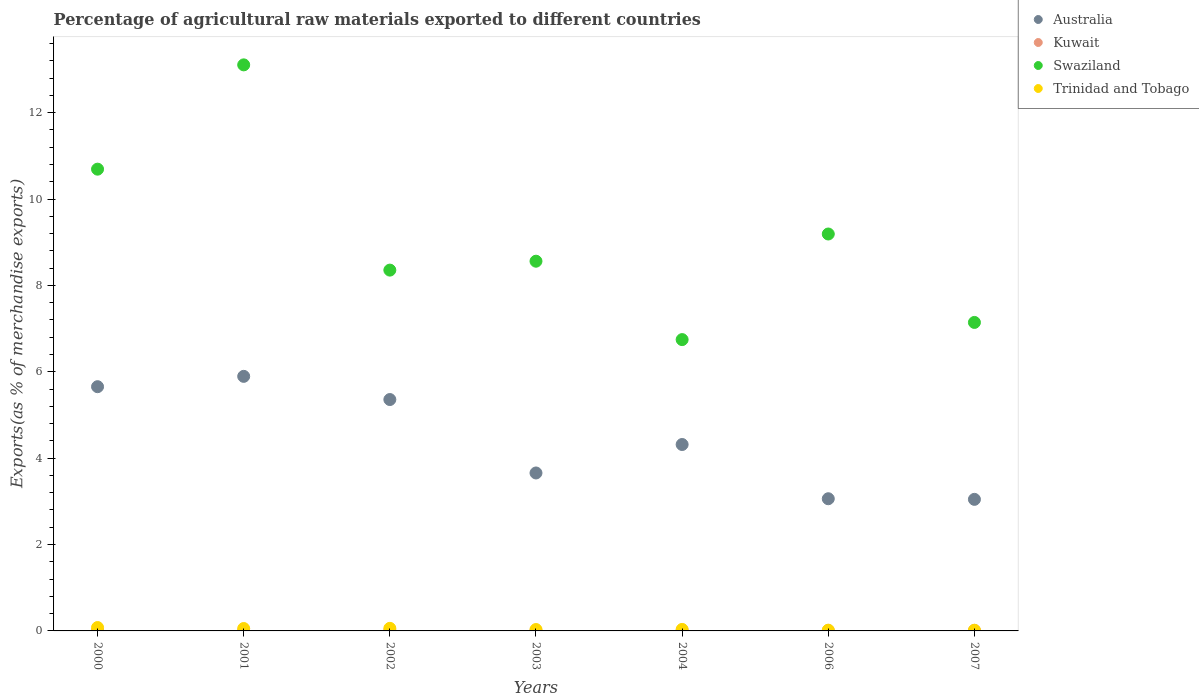Is the number of dotlines equal to the number of legend labels?
Offer a terse response. Yes. What is the percentage of exports to different countries in Trinidad and Tobago in 2002?
Your answer should be compact. 0.06. Across all years, what is the maximum percentage of exports to different countries in Trinidad and Tobago?
Your response must be concise. 0.08. Across all years, what is the minimum percentage of exports to different countries in Trinidad and Tobago?
Your answer should be compact. 0.02. In which year was the percentage of exports to different countries in Swaziland maximum?
Offer a terse response. 2001. What is the total percentage of exports to different countries in Swaziland in the graph?
Offer a very short reply. 63.79. What is the difference between the percentage of exports to different countries in Swaziland in 2001 and that in 2004?
Keep it short and to the point. 6.36. What is the difference between the percentage of exports to different countries in Swaziland in 2003 and the percentage of exports to different countries in Kuwait in 2001?
Ensure brevity in your answer.  8.55. What is the average percentage of exports to different countries in Swaziland per year?
Provide a succinct answer. 9.11. In the year 2007, what is the difference between the percentage of exports to different countries in Swaziland and percentage of exports to different countries in Australia?
Your response must be concise. 4.1. In how many years, is the percentage of exports to different countries in Australia greater than 6.4 %?
Make the answer very short. 0. What is the ratio of the percentage of exports to different countries in Trinidad and Tobago in 2004 to that in 2006?
Offer a terse response. 1.97. Is the percentage of exports to different countries in Swaziland in 2000 less than that in 2002?
Your answer should be very brief. No. Is the difference between the percentage of exports to different countries in Swaziland in 2004 and 2007 greater than the difference between the percentage of exports to different countries in Australia in 2004 and 2007?
Give a very brief answer. No. What is the difference between the highest and the second highest percentage of exports to different countries in Swaziland?
Your answer should be very brief. 2.41. What is the difference between the highest and the lowest percentage of exports to different countries in Australia?
Your response must be concise. 2.85. In how many years, is the percentage of exports to different countries in Kuwait greater than the average percentage of exports to different countries in Kuwait taken over all years?
Offer a very short reply. 3. Is the sum of the percentage of exports to different countries in Swaziland in 2002 and 2007 greater than the maximum percentage of exports to different countries in Trinidad and Tobago across all years?
Your answer should be very brief. Yes. Is it the case that in every year, the sum of the percentage of exports to different countries in Kuwait and percentage of exports to different countries in Australia  is greater than the percentage of exports to different countries in Swaziland?
Your response must be concise. No. How many dotlines are there?
Offer a very short reply. 4. How many years are there in the graph?
Make the answer very short. 7. Are the values on the major ticks of Y-axis written in scientific E-notation?
Your answer should be compact. No. Does the graph contain grids?
Provide a succinct answer. No. How many legend labels are there?
Offer a terse response. 4. How are the legend labels stacked?
Your response must be concise. Vertical. What is the title of the graph?
Keep it short and to the point. Percentage of agricultural raw materials exported to different countries. What is the label or title of the X-axis?
Your answer should be compact. Years. What is the label or title of the Y-axis?
Offer a very short reply. Exports(as % of merchandise exports). What is the Exports(as % of merchandise exports) of Australia in 2000?
Give a very brief answer. 5.65. What is the Exports(as % of merchandise exports) of Kuwait in 2000?
Give a very brief answer. 0.01. What is the Exports(as % of merchandise exports) in Swaziland in 2000?
Your answer should be compact. 10.69. What is the Exports(as % of merchandise exports) in Trinidad and Tobago in 2000?
Your answer should be very brief. 0.08. What is the Exports(as % of merchandise exports) of Australia in 2001?
Your response must be concise. 5.89. What is the Exports(as % of merchandise exports) of Kuwait in 2001?
Your answer should be compact. 0.01. What is the Exports(as % of merchandise exports) in Swaziland in 2001?
Provide a short and direct response. 13.11. What is the Exports(as % of merchandise exports) of Trinidad and Tobago in 2001?
Offer a terse response. 0.06. What is the Exports(as % of merchandise exports) in Australia in 2002?
Offer a very short reply. 5.36. What is the Exports(as % of merchandise exports) in Kuwait in 2002?
Provide a succinct answer. 0.01. What is the Exports(as % of merchandise exports) in Swaziland in 2002?
Your answer should be compact. 8.35. What is the Exports(as % of merchandise exports) in Trinidad and Tobago in 2002?
Give a very brief answer. 0.06. What is the Exports(as % of merchandise exports) of Australia in 2003?
Provide a short and direct response. 3.66. What is the Exports(as % of merchandise exports) in Kuwait in 2003?
Ensure brevity in your answer.  0.01. What is the Exports(as % of merchandise exports) of Swaziland in 2003?
Offer a very short reply. 8.56. What is the Exports(as % of merchandise exports) of Trinidad and Tobago in 2003?
Give a very brief answer. 0.03. What is the Exports(as % of merchandise exports) of Australia in 2004?
Make the answer very short. 4.32. What is the Exports(as % of merchandise exports) in Kuwait in 2004?
Your answer should be compact. 0.01. What is the Exports(as % of merchandise exports) of Swaziland in 2004?
Offer a terse response. 6.74. What is the Exports(as % of merchandise exports) in Trinidad and Tobago in 2004?
Provide a short and direct response. 0.03. What is the Exports(as % of merchandise exports) in Australia in 2006?
Provide a succinct answer. 3.06. What is the Exports(as % of merchandise exports) in Kuwait in 2006?
Make the answer very short. 0.01. What is the Exports(as % of merchandise exports) in Swaziland in 2006?
Provide a short and direct response. 9.19. What is the Exports(as % of merchandise exports) of Trinidad and Tobago in 2006?
Offer a terse response. 0.02. What is the Exports(as % of merchandise exports) in Australia in 2007?
Keep it short and to the point. 3.05. What is the Exports(as % of merchandise exports) of Kuwait in 2007?
Offer a very short reply. 0.01. What is the Exports(as % of merchandise exports) of Swaziland in 2007?
Give a very brief answer. 7.14. What is the Exports(as % of merchandise exports) in Trinidad and Tobago in 2007?
Your answer should be very brief. 0.02. Across all years, what is the maximum Exports(as % of merchandise exports) of Australia?
Your response must be concise. 5.89. Across all years, what is the maximum Exports(as % of merchandise exports) in Kuwait?
Provide a short and direct response. 0.01. Across all years, what is the maximum Exports(as % of merchandise exports) in Swaziland?
Offer a terse response. 13.11. Across all years, what is the maximum Exports(as % of merchandise exports) of Trinidad and Tobago?
Offer a terse response. 0.08. Across all years, what is the minimum Exports(as % of merchandise exports) in Australia?
Give a very brief answer. 3.05. Across all years, what is the minimum Exports(as % of merchandise exports) of Kuwait?
Provide a short and direct response. 0.01. Across all years, what is the minimum Exports(as % of merchandise exports) in Swaziland?
Offer a very short reply. 6.74. Across all years, what is the minimum Exports(as % of merchandise exports) of Trinidad and Tobago?
Make the answer very short. 0.02. What is the total Exports(as % of merchandise exports) of Australia in the graph?
Your answer should be compact. 30.99. What is the total Exports(as % of merchandise exports) of Kuwait in the graph?
Offer a terse response. 0.07. What is the total Exports(as % of merchandise exports) in Swaziland in the graph?
Give a very brief answer. 63.79. What is the total Exports(as % of merchandise exports) in Trinidad and Tobago in the graph?
Offer a very short reply. 0.29. What is the difference between the Exports(as % of merchandise exports) of Australia in 2000 and that in 2001?
Make the answer very short. -0.24. What is the difference between the Exports(as % of merchandise exports) in Kuwait in 2000 and that in 2001?
Provide a short and direct response. 0.01. What is the difference between the Exports(as % of merchandise exports) in Swaziland in 2000 and that in 2001?
Offer a terse response. -2.41. What is the difference between the Exports(as % of merchandise exports) of Trinidad and Tobago in 2000 and that in 2001?
Ensure brevity in your answer.  0.02. What is the difference between the Exports(as % of merchandise exports) of Australia in 2000 and that in 2002?
Keep it short and to the point. 0.3. What is the difference between the Exports(as % of merchandise exports) of Kuwait in 2000 and that in 2002?
Provide a short and direct response. -0. What is the difference between the Exports(as % of merchandise exports) of Swaziland in 2000 and that in 2002?
Your response must be concise. 2.34. What is the difference between the Exports(as % of merchandise exports) of Trinidad and Tobago in 2000 and that in 2002?
Your answer should be compact. 0.02. What is the difference between the Exports(as % of merchandise exports) in Australia in 2000 and that in 2003?
Your answer should be compact. 2. What is the difference between the Exports(as % of merchandise exports) in Kuwait in 2000 and that in 2003?
Make the answer very short. 0.01. What is the difference between the Exports(as % of merchandise exports) in Swaziland in 2000 and that in 2003?
Give a very brief answer. 2.13. What is the difference between the Exports(as % of merchandise exports) of Trinidad and Tobago in 2000 and that in 2003?
Ensure brevity in your answer.  0.05. What is the difference between the Exports(as % of merchandise exports) of Australia in 2000 and that in 2004?
Offer a very short reply. 1.34. What is the difference between the Exports(as % of merchandise exports) of Kuwait in 2000 and that in 2004?
Keep it short and to the point. 0.01. What is the difference between the Exports(as % of merchandise exports) in Swaziland in 2000 and that in 2004?
Offer a very short reply. 3.95. What is the difference between the Exports(as % of merchandise exports) of Trinidad and Tobago in 2000 and that in 2004?
Keep it short and to the point. 0.04. What is the difference between the Exports(as % of merchandise exports) in Australia in 2000 and that in 2006?
Keep it short and to the point. 2.59. What is the difference between the Exports(as % of merchandise exports) of Kuwait in 2000 and that in 2006?
Your response must be concise. 0.01. What is the difference between the Exports(as % of merchandise exports) of Swaziland in 2000 and that in 2006?
Offer a terse response. 1.5. What is the difference between the Exports(as % of merchandise exports) of Trinidad and Tobago in 2000 and that in 2006?
Make the answer very short. 0.06. What is the difference between the Exports(as % of merchandise exports) of Australia in 2000 and that in 2007?
Offer a terse response. 2.61. What is the difference between the Exports(as % of merchandise exports) of Kuwait in 2000 and that in 2007?
Your response must be concise. 0. What is the difference between the Exports(as % of merchandise exports) in Swaziland in 2000 and that in 2007?
Ensure brevity in your answer.  3.55. What is the difference between the Exports(as % of merchandise exports) of Trinidad and Tobago in 2000 and that in 2007?
Keep it short and to the point. 0.06. What is the difference between the Exports(as % of merchandise exports) in Australia in 2001 and that in 2002?
Provide a short and direct response. 0.54. What is the difference between the Exports(as % of merchandise exports) of Kuwait in 2001 and that in 2002?
Offer a very short reply. -0.01. What is the difference between the Exports(as % of merchandise exports) of Swaziland in 2001 and that in 2002?
Give a very brief answer. 4.75. What is the difference between the Exports(as % of merchandise exports) in Trinidad and Tobago in 2001 and that in 2002?
Keep it short and to the point. -0. What is the difference between the Exports(as % of merchandise exports) of Australia in 2001 and that in 2003?
Your answer should be very brief. 2.24. What is the difference between the Exports(as % of merchandise exports) of Kuwait in 2001 and that in 2003?
Your answer should be very brief. 0. What is the difference between the Exports(as % of merchandise exports) in Swaziland in 2001 and that in 2003?
Make the answer very short. 4.55. What is the difference between the Exports(as % of merchandise exports) of Trinidad and Tobago in 2001 and that in 2003?
Provide a short and direct response. 0.02. What is the difference between the Exports(as % of merchandise exports) of Australia in 2001 and that in 2004?
Offer a very short reply. 1.58. What is the difference between the Exports(as % of merchandise exports) in Kuwait in 2001 and that in 2004?
Your answer should be compact. 0. What is the difference between the Exports(as % of merchandise exports) of Swaziland in 2001 and that in 2004?
Keep it short and to the point. 6.36. What is the difference between the Exports(as % of merchandise exports) in Trinidad and Tobago in 2001 and that in 2004?
Keep it short and to the point. 0.02. What is the difference between the Exports(as % of merchandise exports) in Australia in 2001 and that in 2006?
Your response must be concise. 2.83. What is the difference between the Exports(as % of merchandise exports) in Kuwait in 2001 and that in 2006?
Give a very brief answer. 0. What is the difference between the Exports(as % of merchandise exports) in Swaziland in 2001 and that in 2006?
Provide a short and direct response. 3.92. What is the difference between the Exports(as % of merchandise exports) of Trinidad and Tobago in 2001 and that in 2006?
Your response must be concise. 0.04. What is the difference between the Exports(as % of merchandise exports) in Australia in 2001 and that in 2007?
Offer a very short reply. 2.85. What is the difference between the Exports(as % of merchandise exports) in Kuwait in 2001 and that in 2007?
Offer a very short reply. -0. What is the difference between the Exports(as % of merchandise exports) of Swaziland in 2001 and that in 2007?
Offer a very short reply. 5.96. What is the difference between the Exports(as % of merchandise exports) in Trinidad and Tobago in 2001 and that in 2007?
Your answer should be very brief. 0.04. What is the difference between the Exports(as % of merchandise exports) of Australia in 2002 and that in 2003?
Keep it short and to the point. 1.7. What is the difference between the Exports(as % of merchandise exports) in Kuwait in 2002 and that in 2003?
Keep it short and to the point. 0.01. What is the difference between the Exports(as % of merchandise exports) of Swaziland in 2002 and that in 2003?
Make the answer very short. -0.21. What is the difference between the Exports(as % of merchandise exports) in Trinidad and Tobago in 2002 and that in 2003?
Provide a short and direct response. 0.03. What is the difference between the Exports(as % of merchandise exports) in Australia in 2002 and that in 2004?
Make the answer very short. 1.04. What is the difference between the Exports(as % of merchandise exports) in Kuwait in 2002 and that in 2004?
Your response must be concise. 0.01. What is the difference between the Exports(as % of merchandise exports) in Swaziland in 2002 and that in 2004?
Give a very brief answer. 1.61. What is the difference between the Exports(as % of merchandise exports) of Trinidad and Tobago in 2002 and that in 2004?
Your response must be concise. 0.03. What is the difference between the Exports(as % of merchandise exports) in Australia in 2002 and that in 2006?
Your response must be concise. 2.3. What is the difference between the Exports(as % of merchandise exports) in Kuwait in 2002 and that in 2006?
Provide a succinct answer. 0.01. What is the difference between the Exports(as % of merchandise exports) in Swaziland in 2002 and that in 2006?
Offer a terse response. -0.84. What is the difference between the Exports(as % of merchandise exports) in Trinidad and Tobago in 2002 and that in 2006?
Provide a succinct answer. 0.04. What is the difference between the Exports(as % of merchandise exports) of Australia in 2002 and that in 2007?
Provide a succinct answer. 2.31. What is the difference between the Exports(as % of merchandise exports) in Kuwait in 2002 and that in 2007?
Keep it short and to the point. 0. What is the difference between the Exports(as % of merchandise exports) in Swaziland in 2002 and that in 2007?
Offer a terse response. 1.21. What is the difference between the Exports(as % of merchandise exports) in Trinidad and Tobago in 2002 and that in 2007?
Ensure brevity in your answer.  0.04. What is the difference between the Exports(as % of merchandise exports) in Australia in 2003 and that in 2004?
Ensure brevity in your answer.  -0.66. What is the difference between the Exports(as % of merchandise exports) in Kuwait in 2003 and that in 2004?
Give a very brief answer. 0. What is the difference between the Exports(as % of merchandise exports) in Swaziland in 2003 and that in 2004?
Ensure brevity in your answer.  1.82. What is the difference between the Exports(as % of merchandise exports) in Trinidad and Tobago in 2003 and that in 2004?
Keep it short and to the point. -0. What is the difference between the Exports(as % of merchandise exports) of Australia in 2003 and that in 2006?
Offer a terse response. 0.6. What is the difference between the Exports(as % of merchandise exports) in Kuwait in 2003 and that in 2006?
Your answer should be very brief. -0. What is the difference between the Exports(as % of merchandise exports) in Swaziland in 2003 and that in 2006?
Give a very brief answer. -0.63. What is the difference between the Exports(as % of merchandise exports) of Trinidad and Tobago in 2003 and that in 2006?
Keep it short and to the point. 0.01. What is the difference between the Exports(as % of merchandise exports) of Australia in 2003 and that in 2007?
Your answer should be very brief. 0.61. What is the difference between the Exports(as % of merchandise exports) in Kuwait in 2003 and that in 2007?
Offer a very short reply. -0.01. What is the difference between the Exports(as % of merchandise exports) in Swaziland in 2003 and that in 2007?
Give a very brief answer. 1.42. What is the difference between the Exports(as % of merchandise exports) in Trinidad and Tobago in 2003 and that in 2007?
Your answer should be very brief. 0.02. What is the difference between the Exports(as % of merchandise exports) of Australia in 2004 and that in 2006?
Provide a succinct answer. 1.26. What is the difference between the Exports(as % of merchandise exports) of Kuwait in 2004 and that in 2006?
Keep it short and to the point. -0. What is the difference between the Exports(as % of merchandise exports) in Swaziland in 2004 and that in 2006?
Your response must be concise. -2.44. What is the difference between the Exports(as % of merchandise exports) in Trinidad and Tobago in 2004 and that in 2006?
Offer a terse response. 0.02. What is the difference between the Exports(as % of merchandise exports) of Australia in 2004 and that in 2007?
Make the answer very short. 1.27. What is the difference between the Exports(as % of merchandise exports) of Kuwait in 2004 and that in 2007?
Provide a succinct answer. -0.01. What is the difference between the Exports(as % of merchandise exports) in Swaziland in 2004 and that in 2007?
Your answer should be compact. -0.4. What is the difference between the Exports(as % of merchandise exports) of Trinidad and Tobago in 2004 and that in 2007?
Make the answer very short. 0.02. What is the difference between the Exports(as % of merchandise exports) in Australia in 2006 and that in 2007?
Provide a short and direct response. 0.01. What is the difference between the Exports(as % of merchandise exports) of Kuwait in 2006 and that in 2007?
Give a very brief answer. -0. What is the difference between the Exports(as % of merchandise exports) in Swaziland in 2006 and that in 2007?
Offer a very short reply. 2.05. What is the difference between the Exports(as % of merchandise exports) in Trinidad and Tobago in 2006 and that in 2007?
Offer a very short reply. 0. What is the difference between the Exports(as % of merchandise exports) in Australia in 2000 and the Exports(as % of merchandise exports) in Kuwait in 2001?
Your answer should be compact. 5.65. What is the difference between the Exports(as % of merchandise exports) of Australia in 2000 and the Exports(as % of merchandise exports) of Swaziland in 2001?
Your response must be concise. -7.45. What is the difference between the Exports(as % of merchandise exports) in Australia in 2000 and the Exports(as % of merchandise exports) in Trinidad and Tobago in 2001?
Offer a terse response. 5.6. What is the difference between the Exports(as % of merchandise exports) in Kuwait in 2000 and the Exports(as % of merchandise exports) in Swaziland in 2001?
Provide a short and direct response. -13.09. What is the difference between the Exports(as % of merchandise exports) in Kuwait in 2000 and the Exports(as % of merchandise exports) in Trinidad and Tobago in 2001?
Your answer should be very brief. -0.04. What is the difference between the Exports(as % of merchandise exports) in Swaziland in 2000 and the Exports(as % of merchandise exports) in Trinidad and Tobago in 2001?
Provide a short and direct response. 10.64. What is the difference between the Exports(as % of merchandise exports) of Australia in 2000 and the Exports(as % of merchandise exports) of Kuwait in 2002?
Your answer should be compact. 5.64. What is the difference between the Exports(as % of merchandise exports) of Australia in 2000 and the Exports(as % of merchandise exports) of Swaziland in 2002?
Your response must be concise. -2.7. What is the difference between the Exports(as % of merchandise exports) in Australia in 2000 and the Exports(as % of merchandise exports) in Trinidad and Tobago in 2002?
Give a very brief answer. 5.59. What is the difference between the Exports(as % of merchandise exports) of Kuwait in 2000 and the Exports(as % of merchandise exports) of Swaziland in 2002?
Your answer should be compact. -8.34. What is the difference between the Exports(as % of merchandise exports) in Kuwait in 2000 and the Exports(as % of merchandise exports) in Trinidad and Tobago in 2002?
Make the answer very short. -0.05. What is the difference between the Exports(as % of merchandise exports) of Swaziland in 2000 and the Exports(as % of merchandise exports) of Trinidad and Tobago in 2002?
Provide a succinct answer. 10.63. What is the difference between the Exports(as % of merchandise exports) in Australia in 2000 and the Exports(as % of merchandise exports) in Kuwait in 2003?
Provide a short and direct response. 5.65. What is the difference between the Exports(as % of merchandise exports) of Australia in 2000 and the Exports(as % of merchandise exports) of Swaziland in 2003?
Your answer should be compact. -2.91. What is the difference between the Exports(as % of merchandise exports) of Australia in 2000 and the Exports(as % of merchandise exports) of Trinidad and Tobago in 2003?
Provide a short and direct response. 5.62. What is the difference between the Exports(as % of merchandise exports) in Kuwait in 2000 and the Exports(as % of merchandise exports) in Swaziland in 2003?
Offer a very short reply. -8.55. What is the difference between the Exports(as % of merchandise exports) of Kuwait in 2000 and the Exports(as % of merchandise exports) of Trinidad and Tobago in 2003?
Your answer should be compact. -0.02. What is the difference between the Exports(as % of merchandise exports) of Swaziland in 2000 and the Exports(as % of merchandise exports) of Trinidad and Tobago in 2003?
Offer a terse response. 10.66. What is the difference between the Exports(as % of merchandise exports) in Australia in 2000 and the Exports(as % of merchandise exports) in Kuwait in 2004?
Your answer should be very brief. 5.65. What is the difference between the Exports(as % of merchandise exports) of Australia in 2000 and the Exports(as % of merchandise exports) of Swaziland in 2004?
Offer a terse response. -1.09. What is the difference between the Exports(as % of merchandise exports) in Australia in 2000 and the Exports(as % of merchandise exports) in Trinidad and Tobago in 2004?
Ensure brevity in your answer.  5.62. What is the difference between the Exports(as % of merchandise exports) of Kuwait in 2000 and the Exports(as % of merchandise exports) of Swaziland in 2004?
Give a very brief answer. -6.73. What is the difference between the Exports(as % of merchandise exports) in Kuwait in 2000 and the Exports(as % of merchandise exports) in Trinidad and Tobago in 2004?
Keep it short and to the point. -0.02. What is the difference between the Exports(as % of merchandise exports) of Swaziland in 2000 and the Exports(as % of merchandise exports) of Trinidad and Tobago in 2004?
Your answer should be compact. 10.66. What is the difference between the Exports(as % of merchandise exports) of Australia in 2000 and the Exports(as % of merchandise exports) of Kuwait in 2006?
Your answer should be compact. 5.65. What is the difference between the Exports(as % of merchandise exports) of Australia in 2000 and the Exports(as % of merchandise exports) of Swaziland in 2006?
Provide a succinct answer. -3.54. What is the difference between the Exports(as % of merchandise exports) in Australia in 2000 and the Exports(as % of merchandise exports) in Trinidad and Tobago in 2006?
Offer a terse response. 5.64. What is the difference between the Exports(as % of merchandise exports) in Kuwait in 2000 and the Exports(as % of merchandise exports) in Swaziland in 2006?
Offer a terse response. -9.18. What is the difference between the Exports(as % of merchandise exports) of Kuwait in 2000 and the Exports(as % of merchandise exports) of Trinidad and Tobago in 2006?
Ensure brevity in your answer.  -0. What is the difference between the Exports(as % of merchandise exports) in Swaziland in 2000 and the Exports(as % of merchandise exports) in Trinidad and Tobago in 2006?
Give a very brief answer. 10.67. What is the difference between the Exports(as % of merchandise exports) of Australia in 2000 and the Exports(as % of merchandise exports) of Kuwait in 2007?
Offer a very short reply. 5.64. What is the difference between the Exports(as % of merchandise exports) of Australia in 2000 and the Exports(as % of merchandise exports) of Swaziland in 2007?
Offer a very short reply. -1.49. What is the difference between the Exports(as % of merchandise exports) in Australia in 2000 and the Exports(as % of merchandise exports) in Trinidad and Tobago in 2007?
Provide a succinct answer. 5.64. What is the difference between the Exports(as % of merchandise exports) in Kuwait in 2000 and the Exports(as % of merchandise exports) in Swaziland in 2007?
Your answer should be very brief. -7.13. What is the difference between the Exports(as % of merchandise exports) in Kuwait in 2000 and the Exports(as % of merchandise exports) in Trinidad and Tobago in 2007?
Give a very brief answer. -0. What is the difference between the Exports(as % of merchandise exports) in Swaziland in 2000 and the Exports(as % of merchandise exports) in Trinidad and Tobago in 2007?
Provide a short and direct response. 10.68. What is the difference between the Exports(as % of merchandise exports) of Australia in 2001 and the Exports(as % of merchandise exports) of Kuwait in 2002?
Your answer should be compact. 5.88. What is the difference between the Exports(as % of merchandise exports) of Australia in 2001 and the Exports(as % of merchandise exports) of Swaziland in 2002?
Your answer should be compact. -2.46. What is the difference between the Exports(as % of merchandise exports) of Australia in 2001 and the Exports(as % of merchandise exports) of Trinidad and Tobago in 2002?
Your answer should be compact. 5.83. What is the difference between the Exports(as % of merchandise exports) of Kuwait in 2001 and the Exports(as % of merchandise exports) of Swaziland in 2002?
Your answer should be very brief. -8.35. What is the difference between the Exports(as % of merchandise exports) of Kuwait in 2001 and the Exports(as % of merchandise exports) of Trinidad and Tobago in 2002?
Your answer should be very brief. -0.05. What is the difference between the Exports(as % of merchandise exports) of Swaziland in 2001 and the Exports(as % of merchandise exports) of Trinidad and Tobago in 2002?
Offer a very short reply. 13.05. What is the difference between the Exports(as % of merchandise exports) in Australia in 2001 and the Exports(as % of merchandise exports) in Kuwait in 2003?
Offer a very short reply. 5.89. What is the difference between the Exports(as % of merchandise exports) in Australia in 2001 and the Exports(as % of merchandise exports) in Swaziland in 2003?
Ensure brevity in your answer.  -2.67. What is the difference between the Exports(as % of merchandise exports) in Australia in 2001 and the Exports(as % of merchandise exports) in Trinidad and Tobago in 2003?
Offer a terse response. 5.86. What is the difference between the Exports(as % of merchandise exports) of Kuwait in 2001 and the Exports(as % of merchandise exports) of Swaziland in 2003?
Your answer should be compact. -8.55. What is the difference between the Exports(as % of merchandise exports) in Kuwait in 2001 and the Exports(as % of merchandise exports) in Trinidad and Tobago in 2003?
Provide a succinct answer. -0.02. What is the difference between the Exports(as % of merchandise exports) of Swaziland in 2001 and the Exports(as % of merchandise exports) of Trinidad and Tobago in 2003?
Ensure brevity in your answer.  13.07. What is the difference between the Exports(as % of merchandise exports) of Australia in 2001 and the Exports(as % of merchandise exports) of Kuwait in 2004?
Make the answer very short. 5.89. What is the difference between the Exports(as % of merchandise exports) of Australia in 2001 and the Exports(as % of merchandise exports) of Swaziland in 2004?
Give a very brief answer. -0.85. What is the difference between the Exports(as % of merchandise exports) in Australia in 2001 and the Exports(as % of merchandise exports) in Trinidad and Tobago in 2004?
Keep it short and to the point. 5.86. What is the difference between the Exports(as % of merchandise exports) in Kuwait in 2001 and the Exports(as % of merchandise exports) in Swaziland in 2004?
Provide a short and direct response. -6.74. What is the difference between the Exports(as % of merchandise exports) of Kuwait in 2001 and the Exports(as % of merchandise exports) of Trinidad and Tobago in 2004?
Offer a very short reply. -0.03. What is the difference between the Exports(as % of merchandise exports) in Swaziland in 2001 and the Exports(as % of merchandise exports) in Trinidad and Tobago in 2004?
Offer a very short reply. 13.07. What is the difference between the Exports(as % of merchandise exports) in Australia in 2001 and the Exports(as % of merchandise exports) in Kuwait in 2006?
Offer a terse response. 5.89. What is the difference between the Exports(as % of merchandise exports) in Australia in 2001 and the Exports(as % of merchandise exports) in Swaziland in 2006?
Offer a terse response. -3.3. What is the difference between the Exports(as % of merchandise exports) of Australia in 2001 and the Exports(as % of merchandise exports) of Trinidad and Tobago in 2006?
Provide a succinct answer. 5.88. What is the difference between the Exports(as % of merchandise exports) in Kuwait in 2001 and the Exports(as % of merchandise exports) in Swaziland in 2006?
Ensure brevity in your answer.  -9.18. What is the difference between the Exports(as % of merchandise exports) of Kuwait in 2001 and the Exports(as % of merchandise exports) of Trinidad and Tobago in 2006?
Keep it short and to the point. -0.01. What is the difference between the Exports(as % of merchandise exports) in Swaziland in 2001 and the Exports(as % of merchandise exports) in Trinidad and Tobago in 2006?
Keep it short and to the point. 13.09. What is the difference between the Exports(as % of merchandise exports) in Australia in 2001 and the Exports(as % of merchandise exports) in Kuwait in 2007?
Make the answer very short. 5.88. What is the difference between the Exports(as % of merchandise exports) in Australia in 2001 and the Exports(as % of merchandise exports) in Swaziland in 2007?
Your response must be concise. -1.25. What is the difference between the Exports(as % of merchandise exports) of Australia in 2001 and the Exports(as % of merchandise exports) of Trinidad and Tobago in 2007?
Give a very brief answer. 5.88. What is the difference between the Exports(as % of merchandise exports) in Kuwait in 2001 and the Exports(as % of merchandise exports) in Swaziland in 2007?
Provide a succinct answer. -7.13. What is the difference between the Exports(as % of merchandise exports) of Kuwait in 2001 and the Exports(as % of merchandise exports) of Trinidad and Tobago in 2007?
Your answer should be compact. -0.01. What is the difference between the Exports(as % of merchandise exports) in Swaziland in 2001 and the Exports(as % of merchandise exports) in Trinidad and Tobago in 2007?
Ensure brevity in your answer.  13.09. What is the difference between the Exports(as % of merchandise exports) of Australia in 2002 and the Exports(as % of merchandise exports) of Kuwait in 2003?
Your answer should be very brief. 5.35. What is the difference between the Exports(as % of merchandise exports) of Australia in 2002 and the Exports(as % of merchandise exports) of Swaziland in 2003?
Offer a very short reply. -3.2. What is the difference between the Exports(as % of merchandise exports) of Australia in 2002 and the Exports(as % of merchandise exports) of Trinidad and Tobago in 2003?
Your response must be concise. 5.32. What is the difference between the Exports(as % of merchandise exports) in Kuwait in 2002 and the Exports(as % of merchandise exports) in Swaziland in 2003?
Your answer should be very brief. -8.55. What is the difference between the Exports(as % of merchandise exports) in Kuwait in 2002 and the Exports(as % of merchandise exports) in Trinidad and Tobago in 2003?
Your answer should be very brief. -0.02. What is the difference between the Exports(as % of merchandise exports) of Swaziland in 2002 and the Exports(as % of merchandise exports) of Trinidad and Tobago in 2003?
Offer a terse response. 8.32. What is the difference between the Exports(as % of merchandise exports) of Australia in 2002 and the Exports(as % of merchandise exports) of Kuwait in 2004?
Your answer should be very brief. 5.35. What is the difference between the Exports(as % of merchandise exports) of Australia in 2002 and the Exports(as % of merchandise exports) of Swaziland in 2004?
Your answer should be very brief. -1.39. What is the difference between the Exports(as % of merchandise exports) in Australia in 2002 and the Exports(as % of merchandise exports) in Trinidad and Tobago in 2004?
Your answer should be very brief. 5.32. What is the difference between the Exports(as % of merchandise exports) in Kuwait in 2002 and the Exports(as % of merchandise exports) in Swaziland in 2004?
Ensure brevity in your answer.  -6.73. What is the difference between the Exports(as % of merchandise exports) of Kuwait in 2002 and the Exports(as % of merchandise exports) of Trinidad and Tobago in 2004?
Make the answer very short. -0.02. What is the difference between the Exports(as % of merchandise exports) in Swaziland in 2002 and the Exports(as % of merchandise exports) in Trinidad and Tobago in 2004?
Provide a succinct answer. 8.32. What is the difference between the Exports(as % of merchandise exports) of Australia in 2002 and the Exports(as % of merchandise exports) of Kuwait in 2006?
Offer a terse response. 5.35. What is the difference between the Exports(as % of merchandise exports) of Australia in 2002 and the Exports(as % of merchandise exports) of Swaziland in 2006?
Provide a succinct answer. -3.83. What is the difference between the Exports(as % of merchandise exports) of Australia in 2002 and the Exports(as % of merchandise exports) of Trinidad and Tobago in 2006?
Offer a very short reply. 5.34. What is the difference between the Exports(as % of merchandise exports) in Kuwait in 2002 and the Exports(as % of merchandise exports) in Swaziland in 2006?
Ensure brevity in your answer.  -9.18. What is the difference between the Exports(as % of merchandise exports) of Kuwait in 2002 and the Exports(as % of merchandise exports) of Trinidad and Tobago in 2006?
Provide a succinct answer. -0. What is the difference between the Exports(as % of merchandise exports) in Swaziland in 2002 and the Exports(as % of merchandise exports) in Trinidad and Tobago in 2006?
Offer a terse response. 8.34. What is the difference between the Exports(as % of merchandise exports) in Australia in 2002 and the Exports(as % of merchandise exports) in Kuwait in 2007?
Ensure brevity in your answer.  5.34. What is the difference between the Exports(as % of merchandise exports) in Australia in 2002 and the Exports(as % of merchandise exports) in Swaziland in 2007?
Make the answer very short. -1.79. What is the difference between the Exports(as % of merchandise exports) in Australia in 2002 and the Exports(as % of merchandise exports) in Trinidad and Tobago in 2007?
Your answer should be very brief. 5.34. What is the difference between the Exports(as % of merchandise exports) in Kuwait in 2002 and the Exports(as % of merchandise exports) in Swaziland in 2007?
Ensure brevity in your answer.  -7.13. What is the difference between the Exports(as % of merchandise exports) in Kuwait in 2002 and the Exports(as % of merchandise exports) in Trinidad and Tobago in 2007?
Provide a short and direct response. -0. What is the difference between the Exports(as % of merchandise exports) in Swaziland in 2002 and the Exports(as % of merchandise exports) in Trinidad and Tobago in 2007?
Offer a terse response. 8.34. What is the difference between the Exports(as % of merchandise exports) of Australia in 2003 and the Exports(as % of merchandise exports) of Kuwait in 2004?
Offer a very short reply. 3.65. What is the difference between the Exports(as % of merchandise exports) of Australia in 2003 and the Exports(as % of merchandise exports) of Swaziland in 2004?
Make the answer very short. -3.09. What is the difference between the Exports(as % of merchandise exports) of Australia in 2003 and the Exports(as % of merchandise exports) of Trinidad and Tobago in 2004?
Ensure brevity in your answer.  3.62. What is the difference between the Exports(as % of merchandise exports) in Kuwait in 2003 and the Exports(as % of merchandise exports) in Swaziland in 2004?
Your answer should be compact. -6.74. What is the difference between the Exports(as % of merchandise exports) of Kuwait in 2003 and the Exports(as % of merchandise exports) of Trinidad and Tobago in 2004?
Your response must be concise. -0.03. What is the difference between the Exports(as % of merchandise exports) of Swaziland in 2003 and the Exports(as % of merchandise exports) of Trinidad and Tobago in 2004?
Make the answer very short. 8.53. What is the difference between the Exports(as % of merchandise exports) in Australia in 2003 and the Exports(as % of merchandise exports) in Kuwait in 2006?
Offer a very short reply. 3.65. What is the difference between the Exports(as % of merchandise exports) in Australia in 2003 and the Exports(as % of merchandise exports) in Swaziland in 2006?
Your answer should be very brief. -5.53. What is the difference between the Exports(as % of merchandise exports) in Australia in 2003 and the Exports(as % of merchandise exports) in Trinidad and Tobago in 2006?
Ensure brevity in your answer.  3.64. What is the difference between the Exports(as % of merchandise exports) in Kuwait in 2003 and the Exports(as % of merchandise exports) in Swaziland in 2006?
Provide a succinct answer. -9.18. What is the difference between the Exports(as % of merchandise exports) in Kuwait in 2003 and the Exports(as % of merchandise exports) in Trinidad and Tobago in 2006?
Your answer should be compact. -0.01. What is the difference between the Exports(as % of merchandise exports) of Swaziland in 2003 and the Exports(as % of merchandise exports) of Trinidad and Tobago in 2006?
Give a very brief answer. 8.54. What is the difference between the Exports(as % of merchandise exports) in Australia in 2003 and the Exports(as % of merchandise exports) in Kuwait in 2007?
Your answer should be very brief. 3.64. What is the difference between the Exports(as % of merchandise exports) of Australia in 2003 and the Exports(as % of merchandise exports) of Swaziland in 2007?
Offer a very short reply. -3.49. What is the difference between the Exports(as % of merchandise exports) of Australia in 2003 and the Exports(as % of merchandise exports) of Trinidad and Tobago in 2007?
Give a very brief answer. 3.64. What is the difference between the Exports(as % of merchandise exports) of Kuwait in 2003 and the Exports(as % of merchandise exports) of Swaziland in 2007?
Keep it short and to the point. -7.14. What is the difference between the Exports(as % of merchandise exports) in Kuwait in 2003 and the Exports(as % of merchandise exports) in Trinidad and Tobago in 2007?
Ensure brevity in your answer.  -0.01. What is the difference between the Exports(as % of merchandise exports) of Swaziland in 2003 and the Exports(as % of merchandise exports) of Trinidad and Tobago in 2007?
Ensure brevity in your answer.  8.54. What is the difference between the Exports(as % of merchandise exports) in Australia in 2004 and the Exports(as % of merchandise exports) in Kuwait in 2006?
Offer a terse response. 4.31. What is the difference between the Exports(as % of merchandise exports) in Australia in 2004 and the Exports(as % of merchandise exports) in Swaziland in 2006?
Your answer should be very brief. -4.87. What is the difference between the Exports(as % of merchandise exports) of Australia in 2004 and the Exports(as % of merchandise exports) of Trinidad and Tobago in 2006?
Provide a succinct answer. 4.3. What is the difference between the Exports(as % of merchandise exports) in Kuwait in 2004 and the Exports(as % of merchandise exports) in Swaziland in 2006?
Offer a terse response. -9.18. What is the difference between the Exports(as % of merchandise exports) of Kuwait in 2004 and the Exports(as % of merchandise exports) of Trinidad and Tobago in 2006?
Provide a short and direct response. -0.01. What is the difference between the Exports(as % of merchandise exports) of Swaziland in 2004 and the Exports(as % of merchandise exports) of Trinidad and Tobago in 2006?
Give a very brief answer. 6.73. What is the difference between the Exports(as % of merchandise exports) in Australia in 2004 and the Exports(as % of merchandise exports) in Kuwait in 2007?
Ensure brevity in your answer.  4.3. What is the difference between the Exports(as % of merchandise exports) in Australia in 2004 and the Exports(as % of merchandise exports) in Swaziland in 2007?
Your answer should be compact. -2.83. What is the difference between the Exports(as % of merchandise exports) of Australia in 2004 and the Exports(as % of merchandise exports) of Trinidad and Tobago in 2007?
Offer a very short reply. 4.3. What is the difference between the Exports(as % of merchandise exports) in Kuwait in 2004 and the Exports(as % of merchandise exports) in Swaziland in 2007?
Give a very brief answer. -7.14. What is the difference between the Exports(as % of merchandise exports) of Kuwait in 2004 and the Exports(as % of merchandise exports) of Trinidad and Tobago in 2007?
Give a very brief answer. -0.01. What is the difference between the Exports(as % of merchandise exports) in Swaziland in 2004 and the Exports(as % of merchandise exports) in Trinidad and Tobago in 2007?
Offer a terse response. 6.73. What is the difference between the Exports(as % of merchandise exports) in Australia in 2006 and the Exports(as % of merchandise exports) in Kuwait in 2007?
Offer a very short reply. 3.05. What is the difference between the Exports(as % of merchandise exports) in Australia in 2006 and the Exports(as % of merchandise exports) in Swaziland in 2007?
Provide a short and direct response. -4.08. What is the difference between the Exports(as % of merchandise exports) in Australia in 2006 and the Exports(as % of merchandise exports) in Trinidad and Tobago in 2007?
Offer a terse response. 3.04. What is the difference between the Exports(as % of merchandise exports) in Kuwait in 2006 and the Exports(as % of merchandise exports) in Swaziland in 2007?
Offer a very short reply. -7.13. What is the difference between the Exports(as % of merchandise exports) in Kuwait in 2006 and the Exports(as % of merchandise exports) in Trinidad and Tobago in 2007?
Your answer should be very brief. -0.01. What is the difference between the Exports(as % of merchandise exports) in Swaziland in 2006 and the Exports(as % of merchandise exports) in Trinidad and Tobago in 2007?
Provide a succinct answer. 9.17. What is the average Exports(as % of merchandise exports) in Australia per year?
Your answer should be compact. 4.43. What is the average Exports(as % of merchandise exports) in Kuwait per year?
Make the answer very short. 0.01. What is the average Exports(as % of merchandise exports) in Swaziland per year?
Your response must be concise. 9.11. What is the average Exports(as % of merchandise exports) in Trinidad and Tobago per year?
Ensure brevity in your answer.  0.04. In the year 2000, what is the difference between the Exports(as % of merchandise exports) of Australia and Exports(as % of merchandise exports) of Kuwait?
Ensure brevity in your answer.  5.64. In the year 2000, what is the difference between the Exports(as % of merchandise exports) in Australia and Exports(as % of merchandise exports) in Swaziland?
Offer a terse response. -5.04. In the year 2000, what is the difference between the Exports(as % of merchandise exports) in Australia and Exports(as % of merchandise exports) in Trinidad and Tobago?
Provide a short and direct response. 5.58. In the year 2000, what is the difference between the Exports(as % of merchandise exports) of Kuwait and Exports(as % of merchandise exports) of Swaziland?
Your response must be concise. -10.68. In the year 2000, what is the difference between the Exports(as % of merchandise exports) in Kuwait and Exports(as % of merchandise exports) in Trinidad and Tobago?
Ensure brevity in your answer.  -0.06. In the year 2000, what is the difference between the Exports(as % of merchandise exports) in Swaziland and Exports(as % of merchandise exports) in Trinidad and Tobago?
Your answer should be very brief. 10.61. In the year 2001, what is the difference between the Exports(as % of merchandise exports) in Australia and Exports(as % of merchandise exports) in Kuwait?
Your response must be concise. 5.89. In the year 2001, what is the difference between the Exports(as % of merchandise exports) in Australia and Exports(as % of merchandise exports) in Swaziland?
Provide a short and direct response. -7.21. In the year 2001, what is the difference between the Exports(as % of merchandise exports) of Australia and Exports(as % of merchandise exports) of Trinidad and Tobago?
Keep it short and to the point. 5.84. In the year 2001, what is the difference between the Exports(as % of merchandise exports) in Kuwait and Exports(as % of merchandise exports) in Swaziland?
Offer a terse response. -13.1. In the year 2001, what is the difference between the Exports(as % of merchandise exports) in Kuwait and Exports(as % of merchandise exports) in Trinidad and Tobago?
Your answer should be compact. -0.05. In the year 2001, what is the difference between the Exports(as % of merchandise exports) in Swaziland and Exports(as % of merchandise exports) in Trinidad and Tobago?
Make the answer very short. 13.05. In the year 2002, what is the difference between the Exports(as % of merchandise exports) in Australia and Exports(as % of merchandise exports) in Kuwait?
Give a very brief answer. 5.34. In the year 2002, what is the difference between the Exports(as % of merchandise exports) of Australia and Exports(as % of merchandise exports) of Swaziland?
Ensure brevity in your answer.  -3. In the year 2002, what is the difference between the Exports(as % of merchandise exports) in Australia and Exports(as % of merchandise exports) in Trinidad and Tobago?
Your answer should be very brief. 5.3. In the year 2002, what is the difference between the Exports(as % of merchandise exports) of Kuwait and Exports(as % of merchandise exports) of Swaziland?
Make the answer very short. -8.34. In the year 2002, what is the difference between the Exports(as % of merchandise exports) of Kuwait and Exports(as % of merchandise exports) of Trinidad and Tobago?
Ensure brevity in your answer.  -0.05. In the year 2002, what is the difference between the Exports(as % of merchandise exports) of Swaziland and Exports(as % of merchandise exports) of Trinidad and Tobago?
Ensure brevity in your answer.  8.29. In the year 2003, what is the difference between the Exports(as % of merchandise exports) in Australia and Exports(as % of merchandise exports) in Kuwait?
Your response must be concise. 3.65. In the year 2003, what is the difference between the Exports(as % of merchandise exports) in Australia and Exports(as % of merchandise exports) in Swaziland?
Your answer should be very brief. -4.9. In the year 2003, what is the difference between the Exports(as % of merchandise exports) in Australia and Exports(as % of merchandise exports) in Trinidad and Tobago?
Your response must be concise. 3.62. In the year 2003, what is the difference between the Exports(as % of merchandise exports) in Kuwait and Exports(as % of merchandise exports) in Swaziland?
Offer a very short reply. -8.55. In the year 2003, what is the difference between the Exports(as % of merchandise exports) in Kuwait and Exports(as % of merchandise exports) in Trinidad and Tobago?
Offer a terse response. -0.03. In the year 2003, what is the difference between the Exports(as % of merchandise exports) in Swaziland and Exports(as % of merchandise exports) in Trinidad and Tobago?
Offer a very short reply. 8.53. In the year 2004, what is the difference between the Exports(as % of merchandise exports) of Australia and Exports(as % of merchandise exports) of Kuwait?
Offer a terse response. 4.31. In the year 2004, what is the difference between the Exports(as % of merchandise exports) in Australia and Exports(as % of merchandise exports) in Swaziland?
Offer a terse response. -2.43. In the year 2004, what is the difference between the Exports(as % of merchandise exports) of Australia and Exports(as % of merchandise exports) of Trinidad and Tobago?
Provide a succinct answer. 4.28. In the year 2004, what is the difference between the Exports(as % of merchandise exports) of Kuwait and Exports(as % of merchandise exports) of Swaziland?
Make the answer very short. -6.74. In the year 2004, what is the difference between the Exports(as % of merchandise exports) of Kuwait and Exports(as % of merchandise exports) of Trinidad and Tobago?
Keep it short and to the point. -0.03. In the year 2004, what is the difference between the Exports(as % of merchandise exports) of Swaziland and Exports(as % of merchandise exports) of Trinidad and Tobago?
Provide a short and direct response. 6.71. In the year 2006, what is the difference between the Exports(as % of merchandise exports) in Australia and Exports(as % of merchandise exports) in Kuwait?
Make the answer very short. 3.05. In the year 2006, what is the difference between the Exports(as % of merchandise exports) of Australia and Exports(as % of merchandise exports) of Swaziland?
Ensure brevity in your answer.  -6.13. In the year 2006, what is the difference between the Exports(as % of merchandise exports) in Australia and Exports(as % of merchandise exports) in Trinidad and Tobago?
Keep it short and to the point. 3.04. In the year 2006, what is the difference between the Exports(as % of merchandise exports) of Kuwait and Exports(as % of merchandise exports) of Swaziland?
Provide a succinct answer. -9.18. In the year 2006, what is the difference between the Exports(as % of merchandise exports) in Kuwait and Exports(as % of merchandise exports) in Trinidad and Tobago?
Ensure brevity in your answer.  -0.01. In the year 2006, what is the difference between the Exports(as % of merchandise exports) in Swaziland and Exports(as % of merchandise exports) in Trinidad and Tobago?
Provide a short and direct response. 9.17. In the year 2007, what is the difference between the Exports(as % of merchandise exports) in Australia and Exports(as % of merchandise exports) in Kuwait?
Your answer should be compact. 3.03. In the year 2007, what is the difference between the Exports(as % of merchandise exports) in Australia and Exports(as % of merchandise exports) in Swaziland?
Make the answer very short. -4.1. In the year 2007, what is the difference between the Exports(as % of merchandise exports) in Australia and Exports(as % of merchandise exports) in Trinidad and Tobago?
Provide a succinct answer. 3.03. In the year 2007, what is the difference between the Exports(as % of merchandise exports) in Kuwait and Exports(as % of merchandise exports) in Swaziland?
Your response must be concise. -7.13. In the year 2007, what is the difference between the Exports(as % of merchandise exports) of Kuwait and Exports(as % of merchandise exports) of Trinidad and Tobago?
Offer a terse response. -0. In the year 2007, what is the difference between the Exports(as % of merchandise exports) in Swaziland and Exports(as % of merchandise exports) in Trinidad and Tobago?
Ensure brevity in your answer.  7.13. What is the ratio of the Exports(as % of merchandise exports) in Australia in 2000 to that in 2001?
Ensure brevity in your answer.  0.96. What is the ratio of the Exports(as % of merchandise exports) of Kuwait in 2000 to that in 2001?
Keep it short and to the point. 1.68. What is the ratio of the Exports(as % of merchandise exports) in Swaziland in 2000 to that in 2001?
Your answer should be compact. 0.82. What is the ratio of the Exports(as % of merchandise exports) of Trinidad and Tobago in 2000 to that in 2001?
Make the answer very short. 1.41. What is the ratio of the Exports(as % of merchandise exports) of Australia in 2000 to that in 2002?
Ensure brevity in your answer.  1.06. What is the ratio of the Exports(as % of merchandise exports) in Kuwait in 2000 to that in 2002?
Give a very brief answer. 0.99. What is the ratio of the Exports(as % of merchandise exports) of Swaziland in 2000 to that in 2002?
Give a very brief answer. 1.28. What is the ratio of the Exports(as % of merchandise exports) in Trinidad and Tobago in 2000 to that in 2002?
Provide a short and direct response. 1.31. What is the ratio of the Exports(as % of merchandise exports) in Australia in 2000 to that in 2003?
Your answer should be very brief. 1.55. What is the ratio of the Exports(as % of merchandise exports) in Kuwait in 2000 to that in 2003?
Provide a short and direct response. 1.94. What is the ratio of the Exports(as % of merchandise exports) of Swaziland in 2000 to that in 2003?
Make the answer very short. 1.25. What is the ratio of the Exports(as % of merchandise exports) of Trinidad and Tobago in 2000 to that in 2003?
Your answer should be very brief. 2.41. What is the ratio of the Exports(as % of merchandise exports) in Australia in 2000 to that in 2004?
Keep it short and to the point. 1.31. What is the ratio of the Exports(as % of merchandise exports) in Kuwait in 2000 to that in 2004?
Your answer should be very brief. 1.96. What is the ratio of the Exports(as % of merchandise exports) in Swaziland in 2000 to that in 2004?
Your response must be concise. 1.59. What is the ratio of the Exports(as % of merchandise exports) in Trinidad and Tobago in 2000 to that in 2004?
Provide a succinct answer. 2.25. What is the ratio of the Exports(as % of merchandise exports) of Australia in 2000 to that in 2006?
Provide a succinct answer. 1.85. What is the ratio of the Exports(as % of merchandise exports) of Kuwait in 2000 to that in 2006?
Make the answer very short. 1.81. What is the ratio of the Exports(as % of merchandise exports) in Swaziland in 2000 to that in 2006?
Give a very brief answer. 1.16. What is the ratio of the Exports(as % of merchandise exports) in Trinidad and Tobago in 2000 to that in 2006?
Offer a terse response. 4.44. What is the ratio of the Exports(as % of merchandise exports) in Australia in 2000 to that in 2007?
Ensure brevity in your answer.  1.86. What is the ratio of the Exports(as % of merchandise exports) of Kuwait in 2000 to that in 2007?
Provide a succinct answer. 1.1. What is the ratio of the Exports(as % of merchandise exports) in Swaziland in 2000 to that in 2007?
Keep it short and to the point. 1.5. What is the ratio of the Exports(as % of merchandise exports) of Trinidad and Tobago in 2000 to that in 2007?
Offer a terse response. 4.96. What is the ratio of the Exports(as % of merchandise exports) in Australia in 2001 to that in 2002?
Ensure brevity in your answer.  1.1. What is the ratio of the Exports(as % of merchandise exports) in Kuwait in 2001 to that in 2002?
Ensure brevity in your answer.  0.59. What is the ratio of the Exports(as % of merchandise exports) of Swaziland in 2001 to that in 2002?
Your answer should be very brief. 1.57. What is the ratio of the Exports(as % of merchandise exports) of Trinidad and Tobago in 2001 to that in 2002?
Give a very brief answer. 0.93. What is the ratio of the Exports(as % of merchandise exports) in Australia in 2001 to that in 2003?
Offer a very short reply. 1.61. What is the ratio of the Exports(as % of merchandise exports) of Kuwait in 2001 to that in 2003?
Ensure brevity in your answer.  1.16. What is the ratio of the Exports(as % of merchandise exports) of Swaziland in 2001 to that in 2003?
Your response must be concise. 1.53. What is the ratio of the Exports(as % of merchandise exports) of Trinidad and Tobago in 2001 to that in 2003?
Keep it short and to the point. 1.71. What is the ratio of the Exports(as % of merchandise exports) of Australia in 2001 to that in 2004?
Make the answer very short. 1.37. What is the ratio of the Exports(as % of merchandise exports) in Kuwait in 2001 to that in 2004?
Offer a very short reply. 1.17. What is the ratio of the Exports(as % of merchandise exports) in Swaziland in 2001 to that in 2004?
Keep it short and to the point. 1.94. What is the ratio of the Exports(as % of merchandise exports) in Trinidad and Tobago in 2001 to that in 2004?
Provide a succinct answer. 1.6. What is the ratio of the Exports(as % of merchandise exports) of Australia in 2001 to that in 2006?
Offer a terse response. 1.93. What is the ratio of the Exports(as % of merchandise exports) in Kuwait in 2001 to that in 2006?
Your answer should be very brief. 1.08. What is the ratio of the Exports(as % of merchandise exports) in Swaziland in 2001 to that in 2006?
Provide a short and direct response. 1.43. What is the ratio of the Exports(as % of merchandise exports) of Trinidad and Tobago in 2001 to that in 2006?
Your response must be concise. 3.14. What is the ratio of the Exports(as % of merchandise exports) of Australia in 2001 to that in 2007?
Offer a terse response. 1.93. What is the ratio of the Exports(as % of merchandise exports) in Kuwait in 2001 to that in 2007?
Your response must be concise. 0.66. What is the ratio of the Exports(as % of merchandise exports) of Swaziland in 2001 to that in 2007?
Provide a short and direct response. 1.83. What is the ratio of the Exports(as % of merchandise exports) of Trinidad and Tobago in 2001 to that in 2007?
Offer a very short reply. 3.51. What is the ratio of the Exports(as % of merchandise exports) in Australia in 2002 to that in 2003?
Offer a terse response. 1.46. What is the ratio of the Exports(as % of merchandise exports) of Kuwait in 2002 to that in 2003?
Your response must be concise. 1.96. What is the ratio of the Exports(as % of merchandise exports) of Swaziland in 2002 to that in 2003?
Your answer should be very brief. 0.98. What is the ratio of the Exports(as % of merchandise exports) of Trinidad and Tobago in 2002 to that in 2003?
Provide a short and direct response. 1.84. What is the ratio of the Exports(as % of merchandise exports) in Australia in 2002 to that in 2004?
Provide a short and direct response. 1.24. What is the ratio of the Exports(as % of merchandise exports) of Kuwait in 2002 to that in 2004?
Offer a very short reply. 1.97. What is the ratio of the Exports(as % of merchandise exports) in Swaziland in 2002 to that in 2004?
Make the answer very short. 1.24. What is the ratio of the Exports(as % of merchandise exports) of Trinidad and Tobago in 2002 to that in 2004?
Your answer should be very brief. 1.72. What is the ratio of the Exports(as % of merchandise exports) of Australia in 2002 to that in 2006?
Make the answer very short. 1.75. What is the ratio of the Exports(as % of merchandise exports) of Kuwait in 2002 to that in 2006?
Offer a very short reply. 1.82. What is the ratio of the Exports(as % of merchandise exports) of Swaziland in 2002 to that in 2006?
Ensure brevity in your answer.  0.91. What is the ratio of the Exports(as % of merchandise exports) of Trinidad and Tobago in 2002 to that in 2006?
Your answer should be compact. 3.39. What is the ratio of the Exports(as % of merchandise exports) in Australia in 2002 to that in 2007?
Ensure brevity in your answer.  1.76. What is the ratio of the Exports(as % of merchandise exports) of Kuwait in 2002 to that in 2007?
Keep it short and to the point. 1.11. What is the ratio of the Exports(as % of merchandise exports) in Swaziland in 2002 to that in 2007?
Give a very brief answer. 1.17. What is the ratio of the Exports(as % of merchandise exports) in Trinidad and Tobago in 2002 to that in 2007?
Provide a short and direct response. 3.79. What is the ratio of the Exports(as % of merchandise exports) of Australia in 2003 to that in 2004?
Make the answer very short. 0.85. What is the ratio of the Exports(as % of merchandise exports) in Kuwait in 2003 to that in 2004?
Offer a terse response. 1.01. What is the ratio of the Exports(as % of merchandise exports) of Swaziland in 2003 to that in 2004?
Provide a succinct answer. 1.27. What is the ratio of the Exports(as % of merchandise exports) in Trinidad and Tobago in 2003 to that in 2004?
Your answer should be compact. 0.93. What is the ratio of the Exports(as % of merchandise exports) of Australia in 2003 to that in 2006?
Offer a terse response. 1.2. What is the ratio of the Exports(as % of merchandise exports) of Kuwait in 2003 to that in 2006?
Your answer should be very brief. 0.93. What is the ratio of the Exports(as % of merchandise exports) in Swaziland in 2003 to that in 2006?
Your answer should be compact. 0.93. What is the ratio of the Exports(as % of merchandise exports) in Trinidad and Tobago in 2003 to that in 2006?
Provide a short and direct response. 1.84. What is the ratio of the Exports(as % of merchandise exports) of Australia in 2003 to that in 2007?
Your answer should be compact. 1.2. What is the ratio of the Exports(as % of merchandise exports) in Kuwait in 2003 to that in 2007?
Keep it short and to the point. 0.57. What is the ratio of the Exports(as % of merchandise exports) in Swaziland in 2003 to that in 2007?
Offer a terse response. 1.2. What is the ratio of the Exports(as % of merchandise exports) of Trinidad and Tobago in 2003 to that in 2007?
Offer a very short reply. 2.06. What is the ratio of the Exports(as % of merchandise exports) in Australia in 2004 to that in 2006?
Offer a very short reply. 1.41. What is the ratio of the Exports(as % of merchandise exports) in Kuwait in 2004 to that in 2006?
Make the answer very short. 0.92. What is the ratio of the Exports(as % of merchandise exports) of Swaziland in 2004 to that in 2006?
Your response must be concise. 0.73. What is the ratio of the Exports(as % of merchandise exports) of Trinidad and Tobago in 2004 to that in 2006?
Offer a very short reply. 1.97. What is the ratio of the Exports(as % of merchandise exports) of Australia in 2004 to that in 2007?
Your answer should be very brief. 1.42. What is the ratio of the Exports(as % of merchandise exports) of Kuwait in 2004 to that in 2007?
Your answer should be compact. 0.56. What is the ratio of the Exports(as % of merchandise exports) in Swaziland in 2004 to that in 2007?
Keep it short and to the point. 0.94. What is the ratio of the Exports(as % of merchandise exports) in Trinidad and Tobago in 2004 to that in 2007?
Keep it short and to the point. 2.2. What is the ratio of the Exports(as % of merchandise exports) of Australia in 2006 to that in 2007?
Provide a short and direct response. 1. What is the ratio of the Exports(as % of merchandise exports) in Kuwait in 2006 to that in 2007?
Provide a short and direct response. 0.61. What is the ratio of the Exports(as % of merchandise exports) of Swaziland in 2006 to that in 2007?
Your answer should be compact. 1.29. What is the ratio of the Exports(as % of merchandise exports) in Trinidad and Tobago in 2006 to that in 2007?
Ensure brevity in your answer.  1.12. What is the difference between the highest and the second highest Exports(as % of merchandise exports) in Australia?
Ensure brevity in your answer.  0.24. What is the difference between the highest and the second highest Exports(as % of merchandise exports) of Swaziland?
Ensure brevity in your answer.  2.41. What is the difference between the highest and the second highest Exports(as % of merchandise exports) in Trinidad and Tobago?
Provide a succinct answer. 0.02. What is the difference between the highest and the lowest Exports(as % of merchandise exports) of Australia?
Your response must be concise. 2.85. What is the difference between the highest and the lowest Exports(as % of merchandise exports) in Kuwait?
Provide a short and direct response. 0.01. What is the difference between the highest and the lowest Exports(as % of merchandise exports) of Swaziland?
Your answer should be very brief. 6.36. What is the difference between the highest and the lowest Exports(as % of merchandise exports) of Trinidad and Tobago?
Provide a short and direct response. 0.06. 